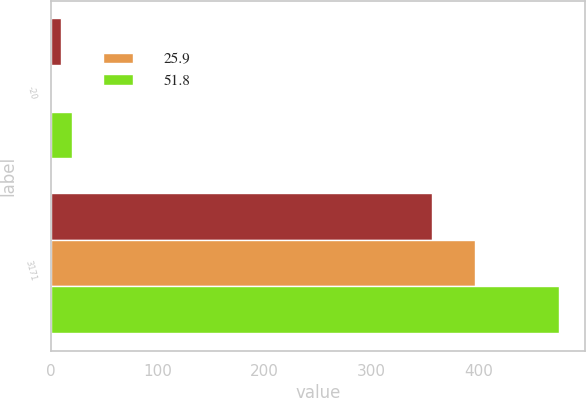<chart> <loc_0><loc_0><loc_500><loc_500><stacked_bar_chart><ecel><fcel>-20<fcel>3171<nl><fcel>nan<fcel>10<fcel>356.7<nl><fcel>25.9<fcel>0<fcel>396.3<nl><fcel>51.8<fcel>20<fcel>475.6<nl></chart> 